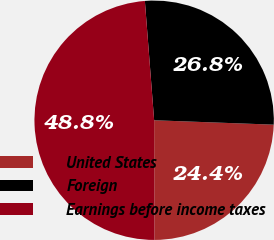Convert chart to OTSL. <chart><loc_0><loc_0><loc_500><loc_500><pie_chart><fcel>United States<fcel>Foreign<fcel>Earnings before income taxes<nl><fcel>24.37%<fcel>26.82%<fcel>48.81%<nl></chart> 